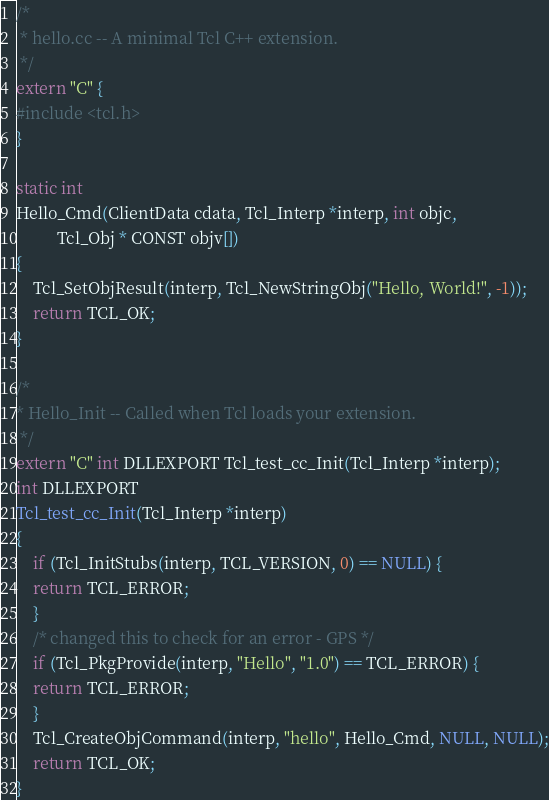Convert code to text. <code><loc_0><loc_0><loc_500><loc_500><_C++_>/*
 * hello.cc -- A minimal Tcl C++ extension.
 */
extern "C" {
#include <tcl.h>
}

static int
Hello_Cmd(ClientData cdata, Tcl_Interp *interp, int objc,
          Tcl_Obj * CONST objv[])
{
    Tcl_SetObjResult(interp, Tcl_NewStringObj("Hello, World!", -1));
    return TCL_OK;
}

/*
* Hello_Init -- Called when Tcl loads your extension.
 */
extern "C" int DLLEXPORT Tcl_test_cc_Init(Tcl_Interp *interp);
int DLLEXPORT
Tcl_test_cc_Init(Tcl_Interp *interp)
{
    if (Tcl_InitStubs(interp, TCL_VERSION, 0) == NULL) {
	return TCL_ERROR;
    }
    /* changed this to check for an error - GPS */
    if (Tcl_PkgProvide(interp, "Hello", "1.0") == TCL_ERROR) {
	return TCL_ERROR;
    }
    Tcl_CreateObjCommand(interp, "hello", Hello_Cmd, NULL, NULL);
    return TCL_OK;
}
</code> 